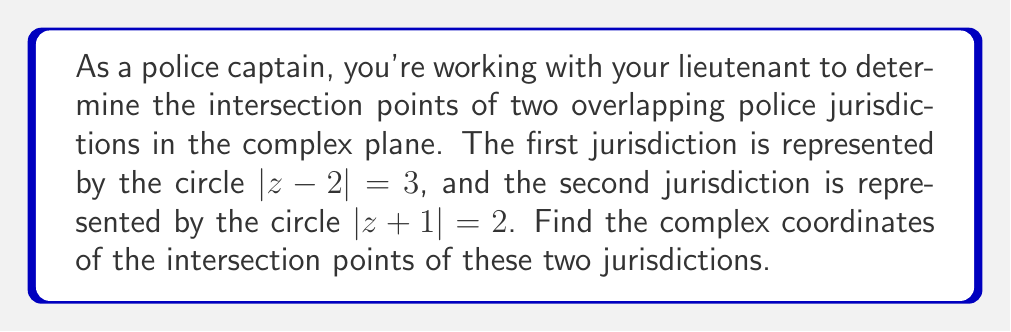Show me your answer to this math problem. To solve this problem, we'll follow these steps:

1) The equations of the two circles are:
   Circle 1: $|z - 2| = 3$
   Circle 2: $|z + 1| = 2$

2) To find the intersection points, we need to solve these equations simultaneously. Let's express $z$ in the form $a + bi$.

3) For Circle 1: $(a + bi - 2)(\overline{a + bi - 2}) = 3^2$
   $((a-2) + bi)((a-2) - bi) = 9$
   $(a-2)^2 + b^2 = 9$ ... (Equation 1)

4) For Circle 2: $(a + bi + 1)(\overline{a + bi + 1}) = 2^2$
   $((a+1) + bi)((a+1) - bi) = 4$
   $(a+1)^2 + b^2 = 4$ ... (Equation 2)

5) Subtracting Equation 2 from Equation 1:
   $(a-2)^2 - (a+1)^2 = 9 - 4$
   $a^2 - 4a + 4 - (a^2 + 2a + 1) = 5$
   $-6a + 3 = 5$
   $-6a = 2$
   $a = -\frac{1}{3}$

6) Substituting this value of $a$ into Equation 2:
   $(-\frac{1}{3}+1)^2 + b^2 = 4$
   $(\frac{2}{3})^2 + b^2 = 4$
   $\frac{4}{9} + b^2 = 4$
   $b^2 = \frac{32}{9}$
   $b = \pm \frac{4\sqrt{2}}{3}$

7) Therefore, the intersection points are:
   $z = -\frac{1}{3} + \frac{4\sqrt{2}}{3}i$ and $z = -\frac{1}{3} - \frac{4\sqrt{2}}{3}i$
Answer: The intersection points of the two police jurisdictions in the complex plane are $-\frac{1}{3} + \frac{4\sqrt{2}}{3}i$ and $-\frac{1}{3} - \frac{4\sqrt{2}}{3}i$. 